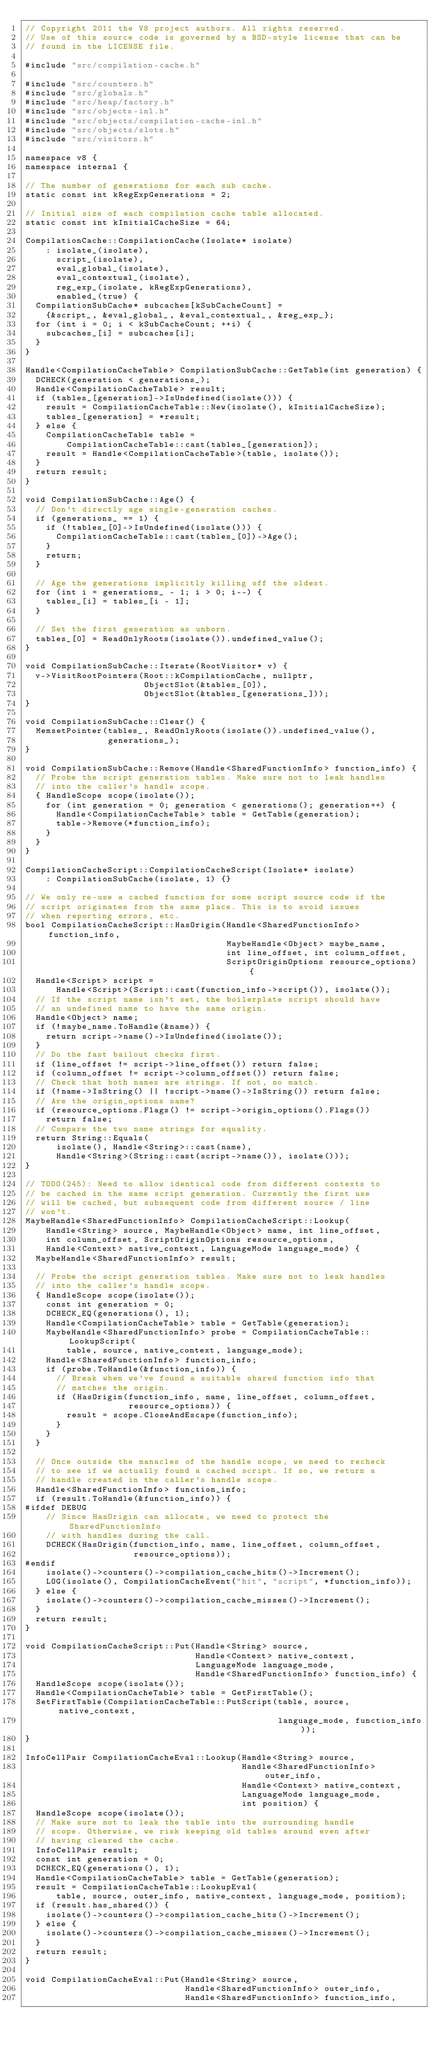<code> <loc_0><loc_0><loc_500><loc_500><_C++_>// Copyright 2011 the V8 project authors. All rights reserved.
// Use of this source code is governed by a BSD-style license that can be
// found in the LICENSE file.

#include "src/compilation-cache.h"

#include "src/counters.h"
#include "src/globals.h"
#include "src/heap/factory.h"
#include "src/objects-inl.h"
#include "src/objects/compilation-cache-inl.h"
#include "src/objects/slots.h"
#include "src/visitors.h"

namespace v8 {
namespace internal {

// The number of generations for each sub cache.
static const int kRegExpGenerations = 2;

// Initial size of each compilation cache table allocated.
static const int kInitialCacheSize = 64;

CompilationCache::CompilationCache(Isolate* isolate)
    : isolate_(isolate),
      script_(isolate),
      eval_global_(isolate),
      eval_contextual_(isolate),
      reg_exp_(isolate, kRegExpGenerations),
      enabled_(true) {
  CompilationSubCache* subcaches[kSubCacheCount] =
    {&script_, &eval_global_, &eval_contextual_, &reg_exp_};
  for (int i = 0; i < kSubCacheCount; ++i) {
    subcaches_[i] = subcaches[i];
  }
}

Handle<CompilationCacheTable> CompilationSubCache::GetTable(int generation) {
  DCHECK(generation < generations_);
  Handle<CompilationCacheTable> result;
  if (tables_[generation]->IsUndefined(isolate())) {
    result = CompilationCacheTable::New(isolate(), kInitialCacheSize);
    tables_[generation] = *result;
  } else {
    CompilationCacheTable table =
        CompilationCacheTable::cast(tables_[generation]);
    result = Handle<CompilationCacheTable>(table, isolate());
  }
  return result;
}

void CompilationSubCache::Age() {
  // Don't directly age single-generation caches.
  if (generations_ == 1) {
    if (!tables_[0]->IsUndefined(isolate())) {
      CompilationCacheTable::cast(tables_[0])->Age();
    }
    return;
  }

  // Age the generations implicitly killing off the oldest.
  for (int i = generations_ - 1; i > 0; i--) {
    tables_[i] = tables_[i - 1];
  }

  // Set the first generation as unborn.
  tables_[0] = ReadOnlyRoots(isolate()).undefined_value();
}

void CompilationSubCache::Iterate(RootVisitor* v) {
  v->VisitRootPointers(Root::kCompilationCache, nullptr,
                       ObjectSlot(&tables_[0]),
                       ObjectSlot(&tables_[generations_]));
}

void CompilationSubCache::Clear() {
  MemsetPointer(tables_, ReadOnlyRoots(isolate()).undefined_value(),
                generations_);
}

void CompilationSubCache::Remove(Handle<SharedFunctionInfo> function_info) {
  // Probe the script generation tables. Make sure not to leak handles
  // into the caller's handle scope.
  { HandleScope scope(isolate());
    for (int generation = 0; generation < generations(); generation++) {
      Handle<CompilationCacheTable> table = GetTable(generation);
      table->Remove(*function_info);
    }
  }
}

CompilationCacheScript::CompilationCacheScript(Isolate* isolate)
    : CompilationSubCache(isolate, 1) {}

// We only re-use a cached function for some script source code if the
// script originates from the same place. This is to avoid issues
// when reporting errors, etc.
bool CompilationCacheScript::HasOrigin(Handle<SharedFunctionInfo> function_info,
                                       MaybeHandle<Object> maybe_name,
                                       int line_offset, int column_offset,
                                       ScriptOriginOptions resource_options) {
  Handle<Script> script =
      Handle<Script>(Script::cast(function_info->script()), isolate());
  // If the script name isn't set, the boilerplate script should have
  // an undefined name to have the same origin.
  Handle<Object> name;
  if (!maybe_name.ToHandle(&name)) {
    return script->name()->IsUndefined(isolate());
  }
  // Do the fast bailout checks first.
  if (line_offset != script->line_offset()) return false;
  if (column_offset != script->column_offset()) return false;
  // Check that both names are strings. If not, no match.
  if (!name->IsString() || !script->name()->IsString()) return false;
  // Are the origin_options same?
  if (resource_options.Flags() != script->origin_options().Flags())
    return false;
  // Compare the two name strings for equality.
  return String::Equals(
      isolate(), Handle<String>::cast(name),
      Handle<String>(String::cast(script->name()), isolate()));
}

// TODO(245): Need to allow identical code from different contexts to
// be cached in the same script generation. Currently the first use
// will be cached, but subsequent code from different source / line
// won't.
MaybeHandle<SharedFunctionInfo> CompilationCacheScript::Lookup(
    Handle<String> source, MaybeHandle<Object> name, int line_offset,
    int column_offset, ScriptOriginOptions resource_options,
    Handle<Context> native_context, LanguageMode language_mode) {
  MaybeHandle<SharedFunctionInfo> result;

  // Probe the script generation tables. Make sure not to leak handles
  // into the caller's handle scope.
  { HandleScope scope(isolate());
    const int generation = 0;
    DCHECK_EQ(generations(), 1);
    Handle<CompilationCacheTable> table = GetTable(generation);
    MaybeHandle<SharedFunctionInfo> probe = CompilationCacheTable::LookupScript(
        table, source, native_context, language_mode);
    Handle<SharedFunctionInfo> function_info;
    if (probe.ToHandle(&function_info)) {
      // Break when we've found a suitable shared function info that
      // matches the origin.
      if (HasOrigin(function_info, name, line_offset, column_offset,
                    resource_options)) {
        result = scope.CloseAndEscape(function_info);
      }
    }
  }

  // Once outside the manacles of the handle scope, we need to recheck
  // to see if we actually found a cached script. If so, we return a
  // handle created in the caller's handle scope.
  Handle<SharedFunctionInfo> function_info;
  if (result.ToHandle(&function_info)) {
#ifdef DEBUG
    // Since HasOrigin can allocate, we need to protect the SharedFunctionInfo
    // with handles during the call.
    DCHECK(HasOrigin(function_info, name, line_offset, column_offset,
                     resource_options));
#endif
    isolate()->counters()->compilation_cache_hits()->Increment();
    LOG(isolate(), CompilationCacheEvent("hit", "script", *function_info));
  } else {
    isolate()->counters()->compilation_cache_misses()->Increment();
  }
  return result;
}

void CompilationCacheScript::Put(Handle<String> source,
                                 Handle<Context> native_context,
                                 LanguageMode language_mode,
                                 Handle<SharedFunctionInfo> function_info) {
  HandleScope scope(isolate());
  Handle<CompilationCacheTable> table = GetFirstTable();
  SetFirstTable(CompilationCacheTable::PutScript(table, source, native_context,
                                                 language_mode, function_info));
}

InfoCellPair CompilationCacheEval::Lookup(Handle<String> source,
                                          Handle<SharedFunctionInfo> outer_info,
                                          Handle<Context> native_context,
                                          LanguageMode language_mode,
                                          int position) {
  HandleScope scope(isolate());
  // Make sure not to leak the table into the surrounding handle
  // scope. Otherwise, we risk keeping old tables around even after
  // having cleared the cache.
  InfoCellPair result;
  const int generation = 0;
  DCHECK_EQ(generations(), 1);
  Handle<CompilationCacheTable> table = GetTable(generation);
  result = CompilationCacheTable::LookupEval(
      table, source, outer_info, native_context, language_mode, position);
  if (result.has_shared()) {
    isolate()->counters()->compilation_cache_hits()->Increment();
  } else {
    isolate()->counters()->compilation_cache_misses()->Increment();
  }
  return result;
}

void CompilationCacheEval::Put(Handle<String> source,
                               Handle<SharedFunctionInfo> outer_info,
                               Handle<SharedFunctionInfo> function_info,</code> 